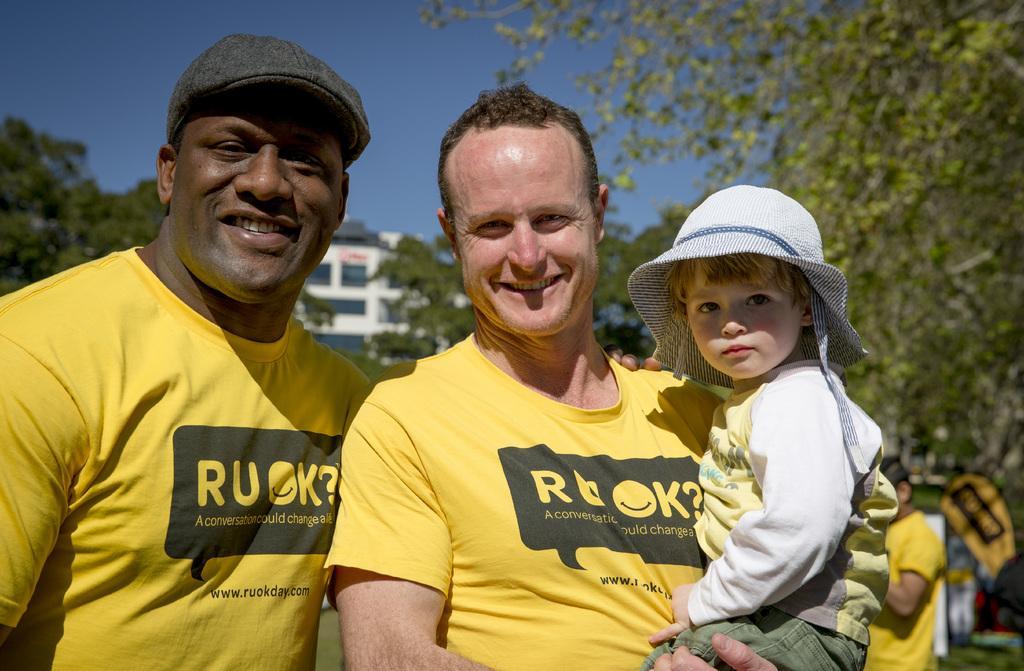Please provide a concise description of this image. 2 people are standing wearing yellow t shirts. The person at the left is wearing a cap and the person at the right is carrying a child. There is another person at the back. There are trees and buildings. 